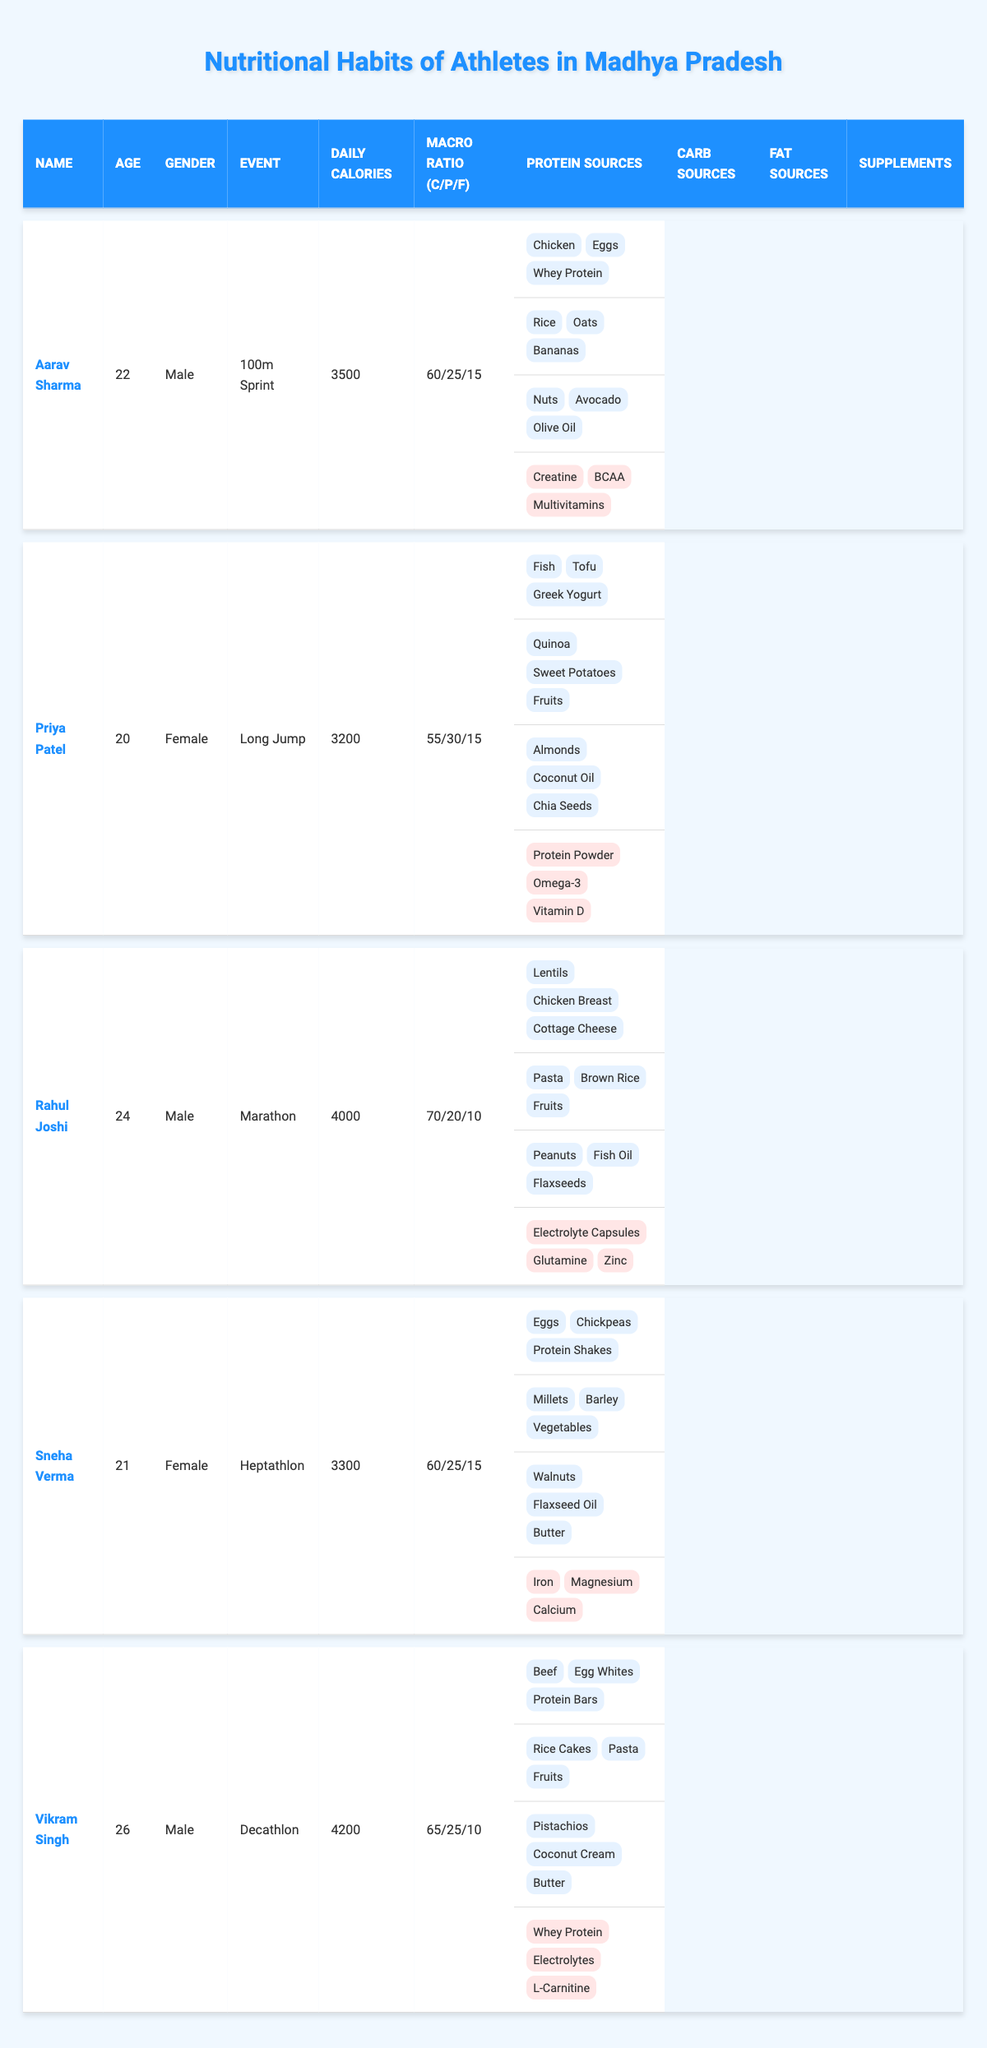What is the daily caloric intake of Aarav Sharma? From the table, under Aarav Sharma's entry, the daily caloric intake is listed as 3500.
Answer: 3500 What percentage of Priya Patel's daily caloric intake is from carbohydrates? The table indicates that Priya Patel has a carbohydrate percentage of 55.
Answer: 55 Who are the athletes with a daily caloric intake higher than 4000? By analyzing the table entries, Rahul Joshi (4000), Vikram Singh (4200) qualify, but Aarav Sharma (3500) and Sneha Verma (3300) do not. Thus, only Vikram Singh exceeds 4000.
Answer: Vikram Singh Which athlete has the highest protein percentage? Upon reviewing the table, Priya Patel's protein percentage is 30, which is the highest compared to others.
Answer: Priya Patel What is the main source of protein for Sneha Verma? The table lists eggs, chickpeas, and protein shakes as the main sources of protein for Sneha Verma; thus any of these is acceptable as her main source.
Answer: Eggs, Chickpeas, or Protein Shakes Is Vikram Singh's protein intake higher than Aarav Sharma's? Vikram Singh's protein percentage is 25, while Aarav Sharma's is also 25. Therefore, they are equal.
Answer: No What is the total percentage of fats across all athletes? The sum of each athlete's fat percentages is (15 + 15 + 10 + 15 + 10) = 65. Because there are 5 athletes, the average is 65/5 = 13. Therefore, the total fat percentage across all athletes is not directly discernible as it represents individual statistics.
Answer: N/A (individual values) Which athlete has a balanced macro ratio of 60/25/15? Looking at the macro ratios presented, both Aarav Sharma and Sneha Verma have a macro ratio of 60/25/15 in the table.
Answer: Aarav Sharma and Sneha Verma What is the average daily caloric intake of the athletes? Summing the daily caloric intakes gives (3500 + 3200 + 4000 + 3300 + 4200) = 18200. Dividing by 5 athletes results in 18200/5 = 3640.
Answer: 3640 Is it true that all athletes take some form of protein supplement? Observing the table, all athletes have a listed supplement related to protein indicating they all take it.
Answer: Yes 